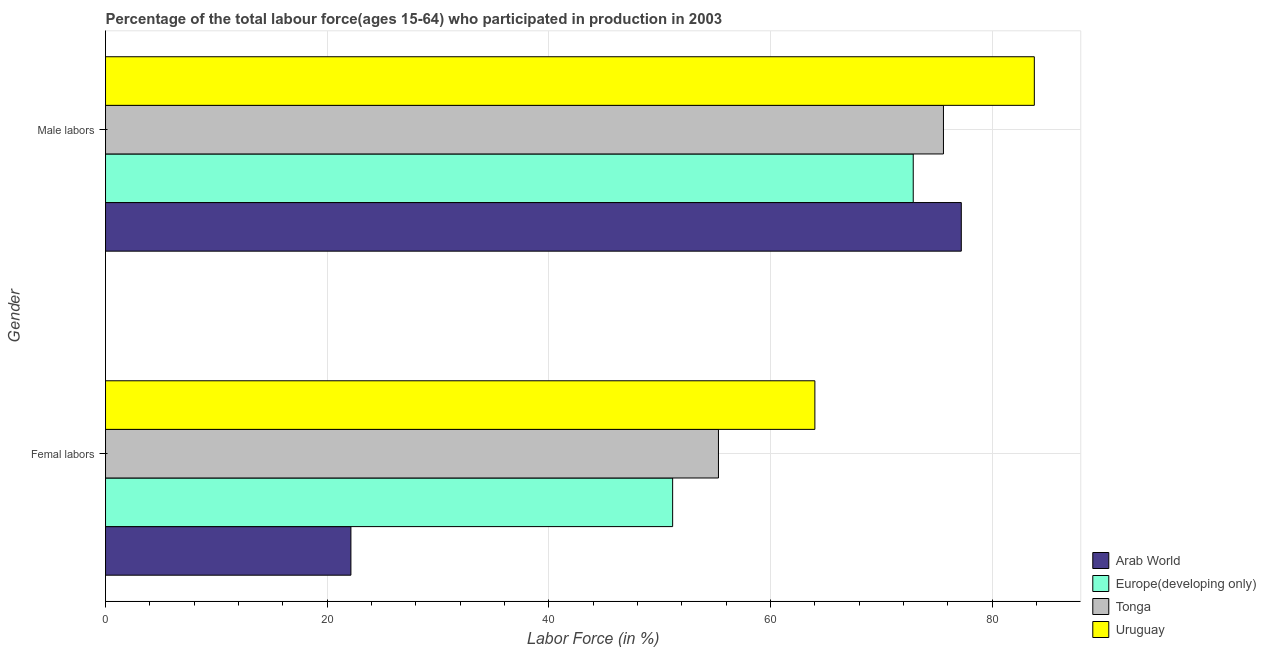What is the label of the 1st group of bars from the top?
Offer a very short reply. Male labors. What is the percentage of female labor force in Europe(developing only)?
Offer a terse response. 51.17. Across all countries, what is the maximum percentage of male labour force?
Your answer should be compact. 83.8. Across all countries, what is the minimum percentage of male labour force?
Make the answer very short. 72.87. In which country was the percentage of female labor force maximum?
Offer a terse response. Uruguay. In which country was the percentage of male labour force minimum?
Your answer should be compact. Europe(developing only). What is the total percentage of female labor force in the graph?
Give a very brief answer. 192.61. What is the difference between the percentage of female labor force in Arab World and that in Uruguay?
Ensure brevity in your answer.  -41.86. What is the difference between the percentage of male labour force in Uruguay and the percentage of female labor force in Tonga?
Provide a succinct answer. 28.5. What is the average percentage of female labor force per country?
Your answer should be very brief. 48.15. What is the difference between the percentage of male labour force and percentage of female labor force in Uruguay?
Provide a short and direct response. 19.8. What is the ratio of the percentage of male labour force in Tonga to that in Uruguay?
Offer a very short reply. 0.9. Is the percentage of female labor force in Tonga less than that in Europe(developing only)?
Offer a very short reply. No. In how many countries, is the percentage of female labor force greater than the average percentage of female labor force taken over all countries?
Keep it short and to the point. 3. What does the 1st bar from the top in Male labors represents?
Provide a succinct answer. Uruguay. What does the 2nd bar from the bottom in Femal labors represents?
Provide a succinct answer. Europe(developing only). Are all the bars in the graph horizontal?
Offer a very short reply. Yes. How many countries are there in the graph?
Make the answer very short. 4. Are the values on the major ticks of X-axis written in scientific E-notation?
Provide a short and direct response. No. Does the graph contain any zero values?
Offer a terse response. No. Where does the legend appear in the graph?
Give a very brief answer. Bottom right. How many legend labels are there?
Make the answer very short. 4. How are the legend labels stacked?
Offer a terse response. Vertical. What is the title of the graph?
Keep it short and to the point. Percentage of the total labour force(ages 15-64) who participated in production in 2003. Does "Cyprus" appear as one of the legend labels in the graph?
Offer a very short reply. No. What is the label or title of the Y-axis?
Offer a very short reply. Gender. What is the Labor Force (in %) in Arab World in Femal labors?
Offer a terse response. 22.14. What is the Labor Force (in %) of Europe(developing only) in Femal labors?
Offer a very short reply. 51.17. What is the Labor Force (in %) in Tonga in Femal labors?
Make the answer very short. 55.3. What is the Labor Force (in %) of Uruguay in Femal labors?
Keep it short and to the point. 64. What is the Labor Force (in %) of Arab World in Male labors?
Give a very brief answer. 77.21. What is the Labor Force (in %) in Europe(developing only) in Male labors?
Your response must be concise. 72.87. What is the Labor Force (in %) in Tonga in Male labors?
Make the answer very short. 75.6. What is the Labor Force (in %) in Uruguay in Male labors?
Offer a very short reply. 83.8. Across all Gender, what is the maximum Labor Force (in %) of Arab World?
Make the answer very short. 77.21. Across all Gender, what is the maximum Labor Force (in %) in Europe(developing only)?
Give a very brief answer. 72.87. Across all Gender, what is the maximum Labor Force (in %) in Tonga?
Your answer should be compact. 75.6. Across all Gender, what is the maximum Labor Force (in %) in Uruguay?
Your response must be concise. 83.8. Across all Gender, what is the minimum Labor Force (in %) of Arab World?
Ensure brevity in your answer.  22.14. Across all Gender, what is the minimum Labor Force (in %) of Europe(developing only)?
Your answer should be very brief. 51.17. Across all Gender, what is the minimum Labor Force (in %) in Tonga?
Your answer should be very brief. 55.3. Across all Gender, what is the minimum Labor Force (in %) of Uruguay?
Offer a very short reply. 64. What is the total Labor Force (in %) in Arab World in the graph?
Provide a succinct answer. 99.35. What is the total Labor Force (in %) in Europe(developing only) in the graph?
Ensure brevity in your answer.  124.04. What is the total Labor Force (in %) of Tonga in the graph?
Ensure brevity in your answer.  130.9. What is the total Labor Force (in %) in Uruguay in the graph?
Offer a very short reply. 147.8. What is the difference between the Labor Force (in %) in Arab World in Femal labors and that in Male labors?
Offer a terse response. -55.07. What is the difference between the Labor Force (in %) in Europe(developing only) in Femal labors and that in Male labors?
Keep it short and to the point. -21.71. What is the difference between the Labor Force (in %) of Tonga in Femal labors and that in Male labors?
Offer a terse response. -20.3. What is the difference between the Labor Force (in %) of Uruguay in Femal labors and that in Male labors?
Ensure brevity in your answer.  -19.8. What is the difference between the Labor Force (in %) of Arab World in Femal labors and the Labor Force (in %) of Europe(developing only) in Male labors?
Your answer should be very brief. -50.73. What is the difference between the Labor Force (in %) in Arab World in Femal labors and the Labor Force (in %) in Tonga in Male labors?
Your answer should be compact. -53.46. What is the difference between the Labor Force (in %) of Arab World in Femal labors and the Labor Force (in %) of Uruguay in Male labors?
Your answer should be very brief. -61.66. What is the difference between the Labor Force (in %) of Europe(developing only) in Femal labors and the Labor Force (in %) of Tonga in Male labors?
Make the answer very short. -24.43. What is the difference between the Labor Force (in %) of Europe(developing only) in Femal labors and the Labor Force (in %) of Uruguay in Male labors?
Provide a short and direct response. -32.63. What is the difference between the Labor Force (in %) in Tonga in Femal labors and the Labor Force (in %) in Uruguay in Male labors?
Offer a very short reply. -28.5. What is the average Labor Force (in %) in Arab World per Gender?
Your answer should be very brief. 49.67. What is the average Labor Force (in %) of Europe(developing only) per Gender?
Your answer should be compact. 62.02. What is the average Labor Force (in %) of Tonga per Gender?
Provide a succinct answer. 65.45. What is the average Labor Force (in %) of Uruguay per Gender?
Keep it short and to the point. 73.9. What is the difference between the Labor Force (in %) in Arab World and Labor Force (in %) in Europe(developing only) in Femal labors?
Your answer should be compact. -29.03. What is the difference between the Labor Force (in %) of Arab World and Labor Force (in %) of Tonga in Femal labors?
Keep it short and to the point. -33.16. What is the difference between the Labor Force (in %) of Arab World and Labor Force (in %) of Uruguay in Femal labors?
Make the answer very short. -41.86. What is the difference between the Labor Force (in %) in Europe(developing only) and Labor Force (in %) in Tonga in Femal labors?
Your response must be concise. -4.13. What is the difference between the Labor Force (in %) of Europe(developing only) and Labor Force (in %) of Uruguay in Femal labors?
Your response must be concise. -12.83. What is the difference between the Labor Force (in %) in Tonga and Labor Force (in %) in Uruguay in Femal labors?
Offer a terse response. -8.7. What is the difference between the Labor Force (in %) of Arab World and Labor Force (in %) of Europe(developing only) in Male labors?
Ensure brevity in your answer.  4.34. What is the difference between the Labor Force (in %) in Arab World and Labor Force (in %) in Tonga in Male labors?
Offer a very short reply. 1.61. What is the difference between the Labor Force (in %) of Arab World and Labor Force (in %) of Uruguay in Male labors?
Your response must be concise. -6.59. What is the difference between the Labor Force (in %) in Europe(developing only) and Labor Force (in %) in Tonga in Male labors?
Offer a very short reply. -2.73. What is the difference between the Labor Force (in %) in Europe(developing only) and Labor Force (in %) in Uruguay in Male labors?
Offer a terse response. -10.93. What is the ratio of the Labor Force (in %) in Arab World in Femal labors to that in Male labors?
Offer a terse response. 0.29. What is the ratio of the Labor Force (in %) in Europe(developing only) in Femal labors to that in Male labors?
Give a very brief answer. 0.7. What is the ratio of the Labor Force (in %) in Tonga in Femal labors to that in Male labors?
Provide a succinct answer. 0.73. What is the ratio of the Labor Force (in %) in Uruguay in Femal labors to that in Male labors?
Provide a succinct answer. 0.76. What is the difference between the highest and the second highest Labor Force (in %) in Arab World?
Provide a short and direct response. 55.07. What is the difference between the highest and the second highest Labor Force (in %) of Europe(developing only)?
Give a very brief answer. 21.71. What is the difference between the highest and the second highest Labor Force (in %) of Tonga?
Ensure brevity in your answer.  20.3. What is the difference between the highest and the second highest Labor Force (in %) of Uruguay?
Your answer should be very brief. 19.8. What is the difference between the highest and the lowest Labor Force (in %) in Arab World?
Offer a terse response. 55.07. What is the difference between the highest and the lowest Labor Force (in %) of Europe(developing only)?
Give a very brief answer. 21.71. What is the difference between the highest and the lowest Labor Force (in %) of Tonga?
Offer a very short reply. 20.3. What is the difference between the highest and the lowest Labor Force (in %) of Uruguay?
Make the answer very short. 19.8. 